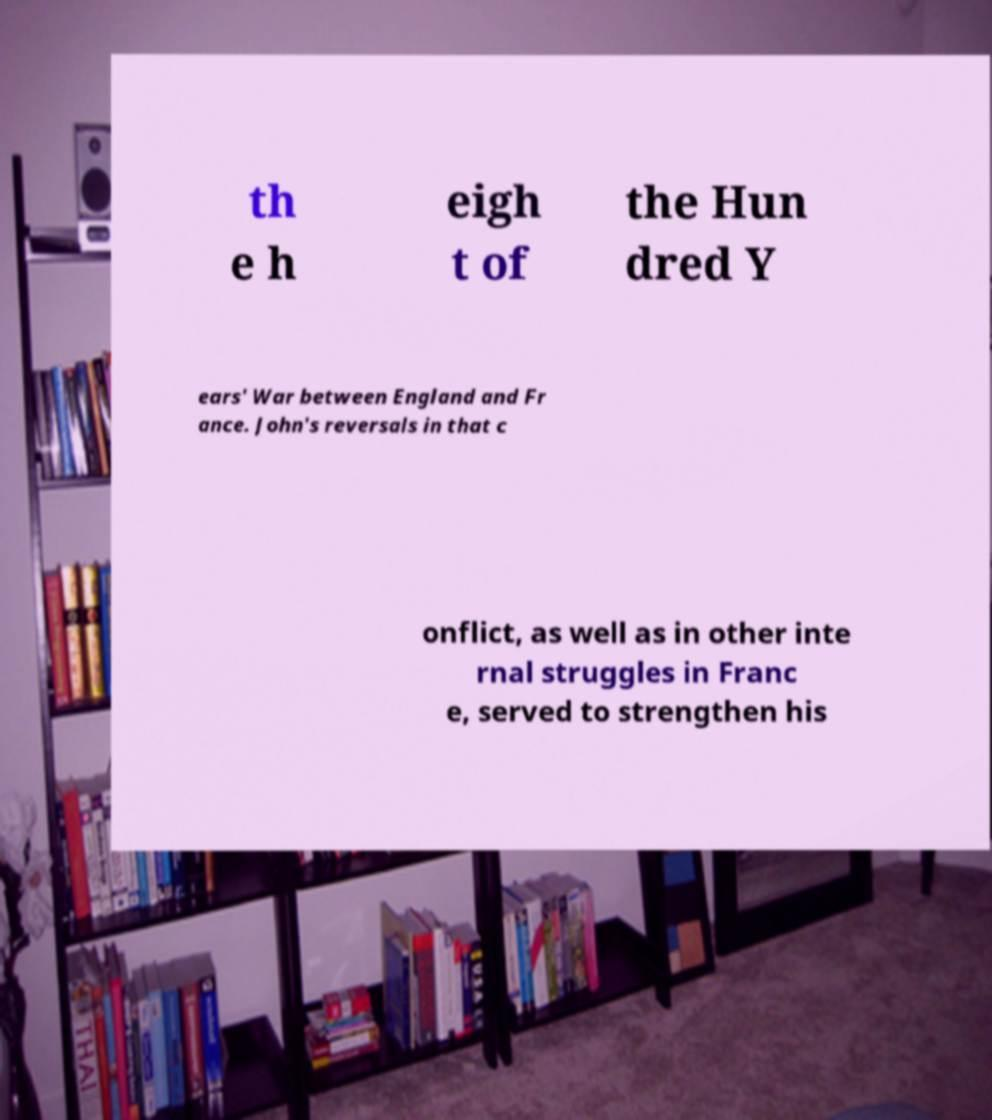Can you accurately transcribe the text from the provided image for me? th e h eigh t of the Hun dred Y ears' War between England and Fr ance. John's reversals in that c onflict, as well as in other inte rnal struggles in Franc e, served to strengthen his 